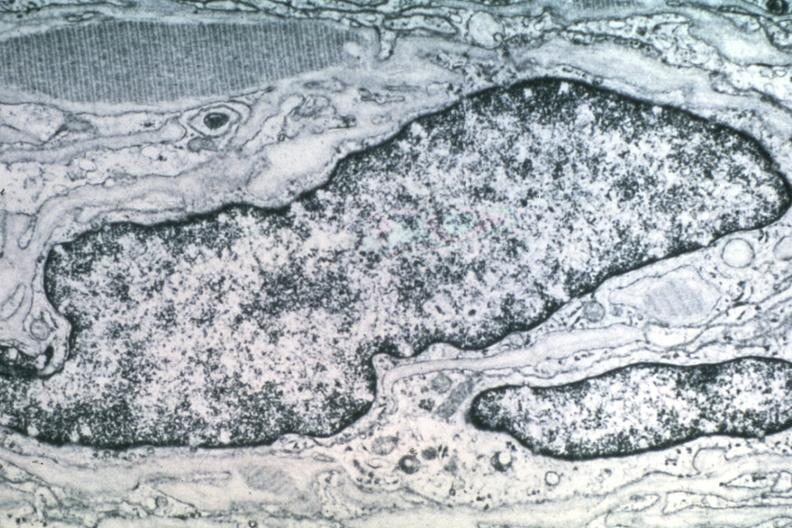what is present?
Answer the question using a single word or phrase. Brain 